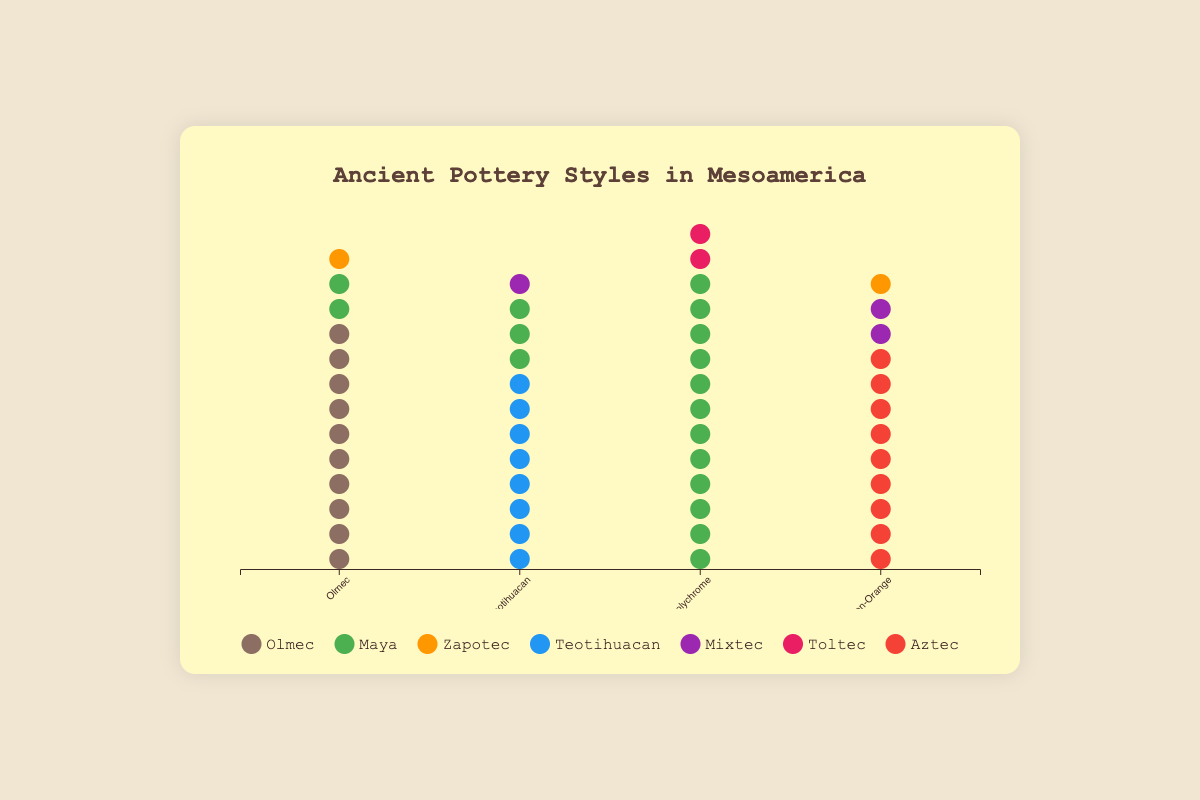what is the title of the figure? The title is usually displayed at the top of the figure in a large or bold font. In this case, the title of the figure is "Ancient Pottery Styles in Mesoamerica".
Answer: Ancient Pottery Styles in Mesoamerica How many pottery styles are shown in the chart? Count the number of unique pottery styles listed along the x-axis. Based on the data, the pottery styles are "Olmec," "Teotihuacan," "Maya Polychrome," and "Aztec Black-on-Orange," totaling four styles.
Answer: Four What color represents the Maya culture in the plot? Each culture is represented by a unique color as shown in the legend. By checking the legend, we see that the color green represents the Maya culture.
Answer: Green How many Olmec style pottery pieces were found across all cultures? Sum the counts of Olmec style pottery pieces found in the Olmec, Maya, and Zapotec cultures. The counts are 10 + 2 + 1, which equals 13 pieces in total.
Answer: 13 Which pottery style is most commonly associated with the Maya culture? Look at the figures for the Maya culture across different pottery styles. The counts are: Olmec (2), Teotihuacan (3), Maya Polychrome (12). The style with the highest count for Maya is Maya Polychrome with 12 items.
Answer: Maya Polychrome For the Aztec Black-on-Orange style, how does the number of pottery pieces found in the Mixtec culture compare to those found in the Zapotec culture? Check the values for Mixtec and Zapotec cultures for the Aztec Black-on-Orange style. There are 2 pieces in Mixtec and 1 in Zapotec. Comparing them, Mixtec has more pieces than Zapotec.
Answer: Mixtec has more What is the total number of pottery pieces for Teotihuacan style? Sum the counts of Teotihuacan style pottery pieces for all cultures: Teotihuacan (8), Maya (3), Mixtec (1). The total is 8 + 3 + 1, which equals 12 pieces.
Answer: 12 Which culture has the highest number of pottery pieces for any single style? Look for the highest count of pottery pieces in the table. The Maya culture has 12 pieces of Maya Polychrome, which is the highest single count across all styles and cultures.
Answer: Maya What is the average number of pottery pieces found for the Olmec culture across all styles? Calculate the average by summing the pottery counts for the Olmec culture across all styles and dividing by the number of styles. For Olmec: 10 (Olmec) + 0 (Teotihuacan) + 0 (Maya Polychrome) + 0 (Aztec Black-on-Orange) = 10. Since only one style has data, the average is 10/1 = 10.
Answer: 10 